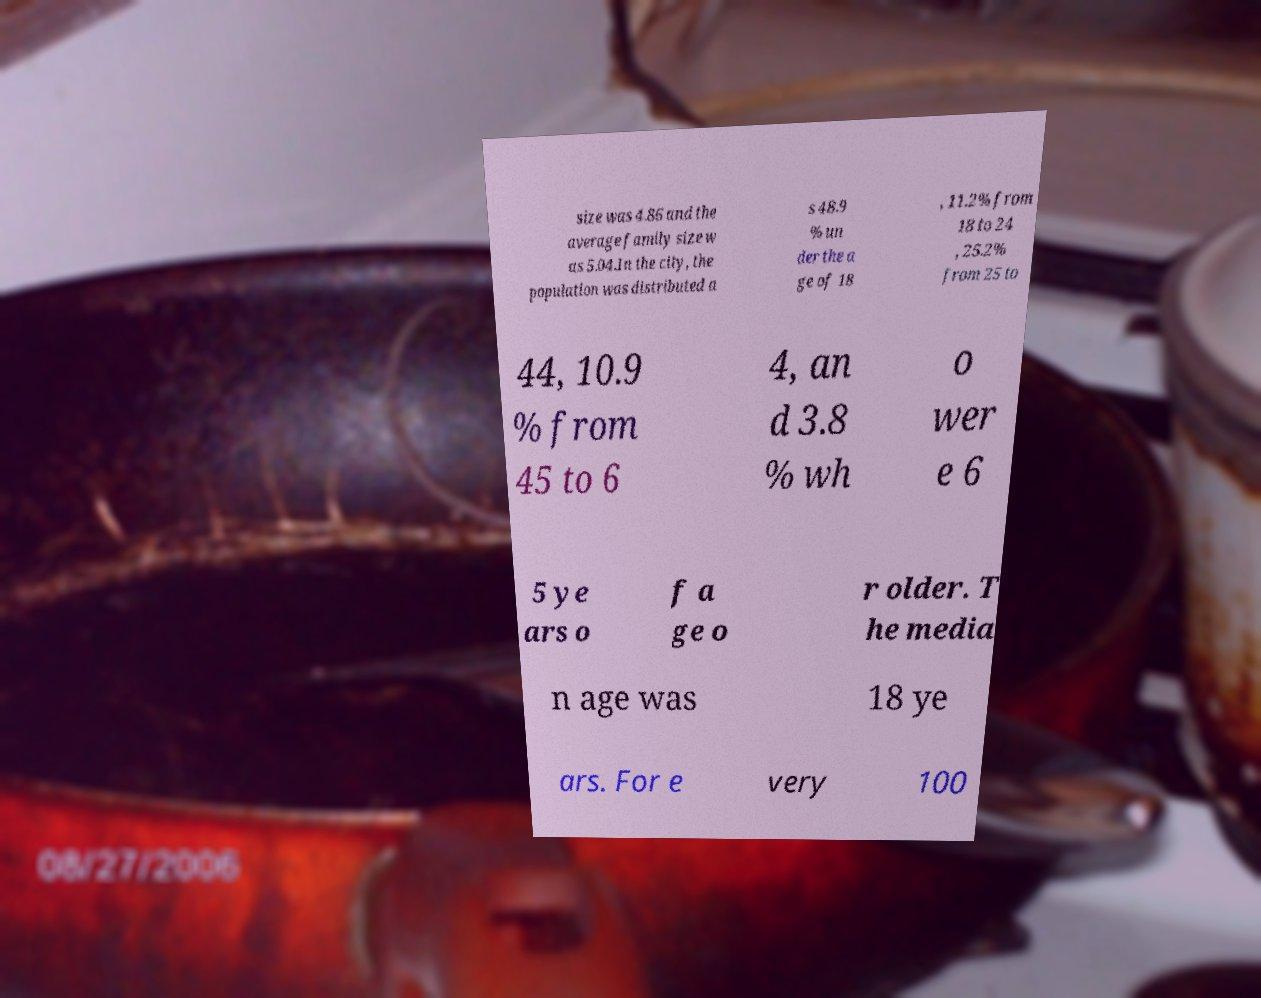Can you read and provide the text displayed in the image?This photo seems to have some interesting text. Can you extract and type it out for me? size was 4.86 and the average family size w as 5.04.In the city, the population was distributed a s 48.9 % un der the a ge of 18 , 11.2% from 18 to 24 , 25.2% from 25 to 44, 10.9 % from 45 to 6 4, an d 3.8 % wh o wer e 6 5 ye ars o f a ge o r older. T he media n age was 18 ye ars. For e very 100 